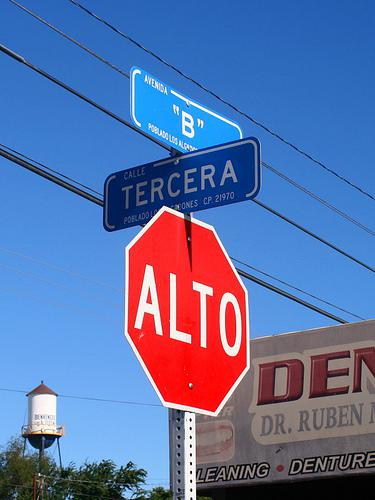Question: where is this picture taken?
Choices:
A. From a balcony.
B. A street corner.
C. At the fair.
D. From a boat.
Answer with the letter. Answer: B Question: what color is the octagon sign?
Choices:
A. Red.
B. Green.
C. Silver.
D. White.
Answer with the letter. Answer: A Question: what color is the street sign?
Choices:
A. Red and silver.
B. Blue and white.
C. Yellow and black.
D. Green and white.
Answer with the letter. Answer: B Question: what streets cross here?
Choices:
A. Main and broadway.
B. First and main.
C. Tercera and B.
D. Polk and cotton.
Answer with the letter. Answer: C 